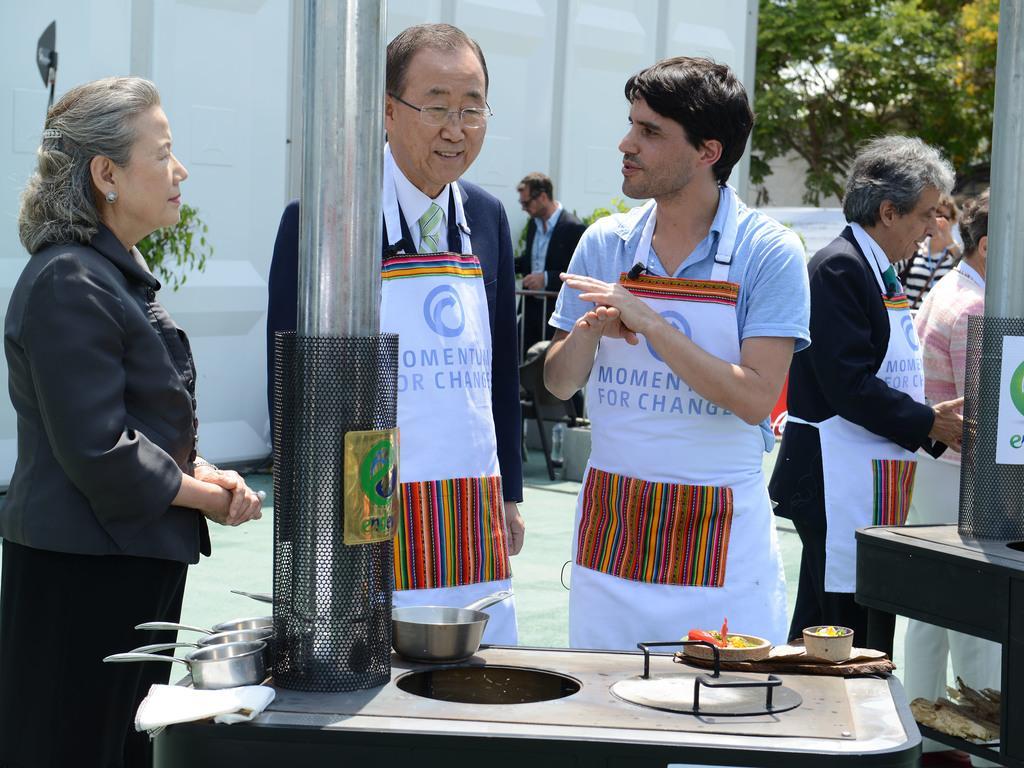Please provide a concise description of this image. In this picture I can see people standing on the surface. I can see bowls. I can see food items. 